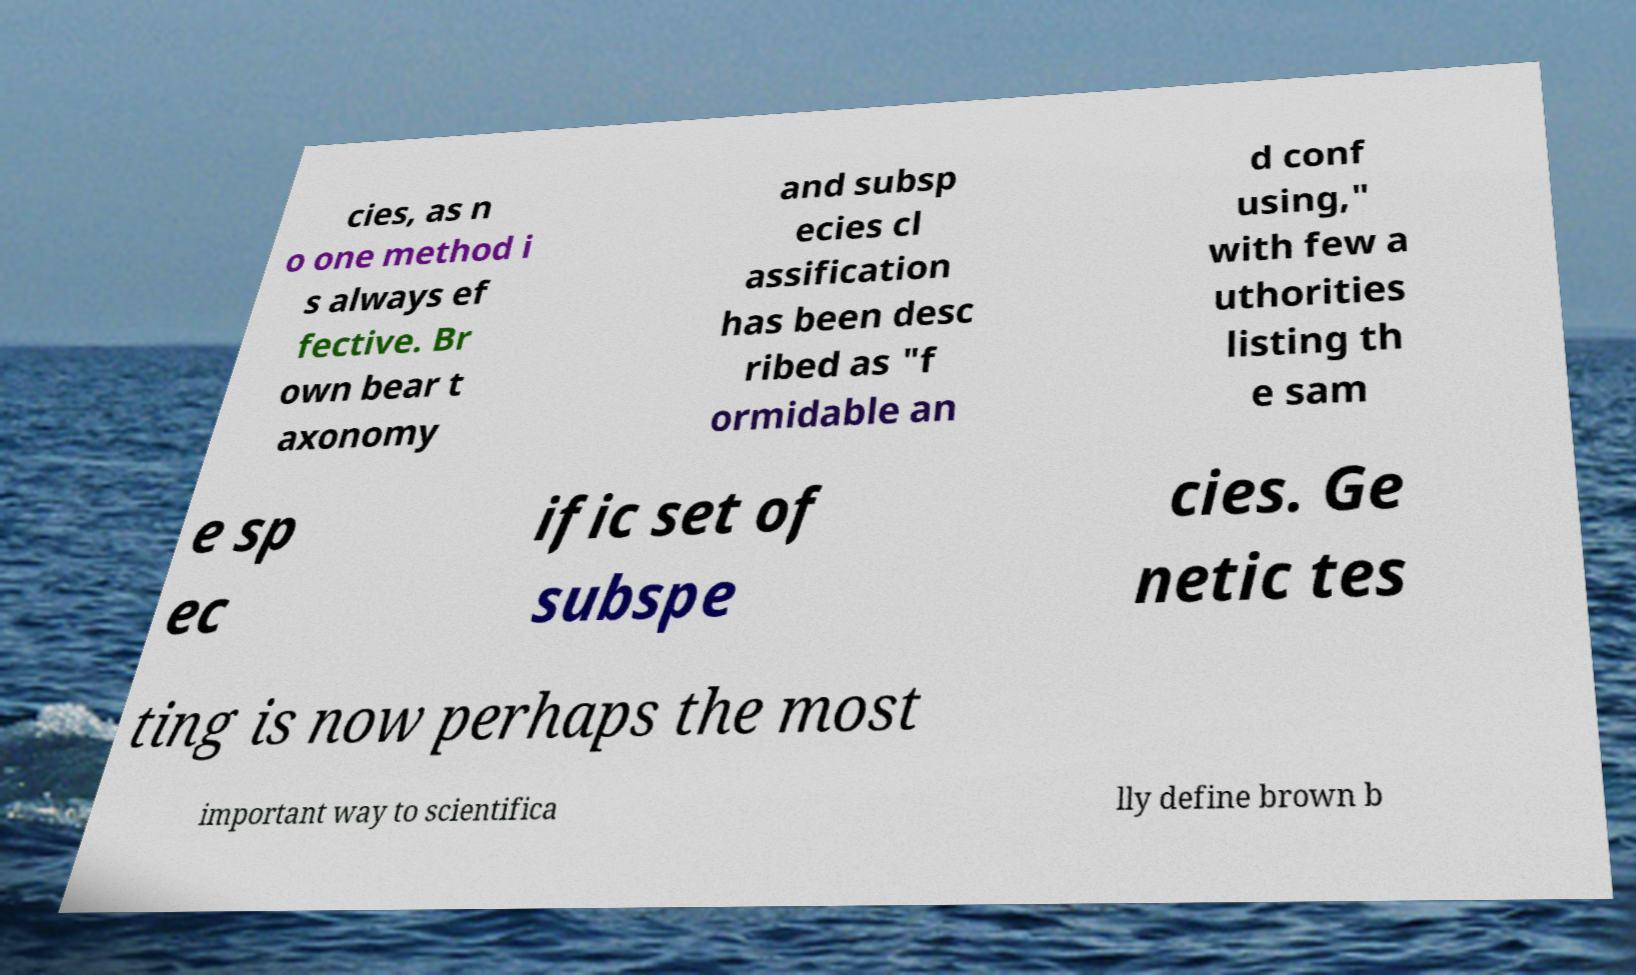Please identify and transcribe the text found in this image. cies, as n o one method i s always ef fective. Br own bear t axonomy and subsp ecies cl assification has been desc ribed as "f ormidable an d conf using," with few a uthorities listing th e sam e sp ec ific set of subspe cies. Ge netic tes ting is now perhaps the most important way to scientifica lly define brown b 